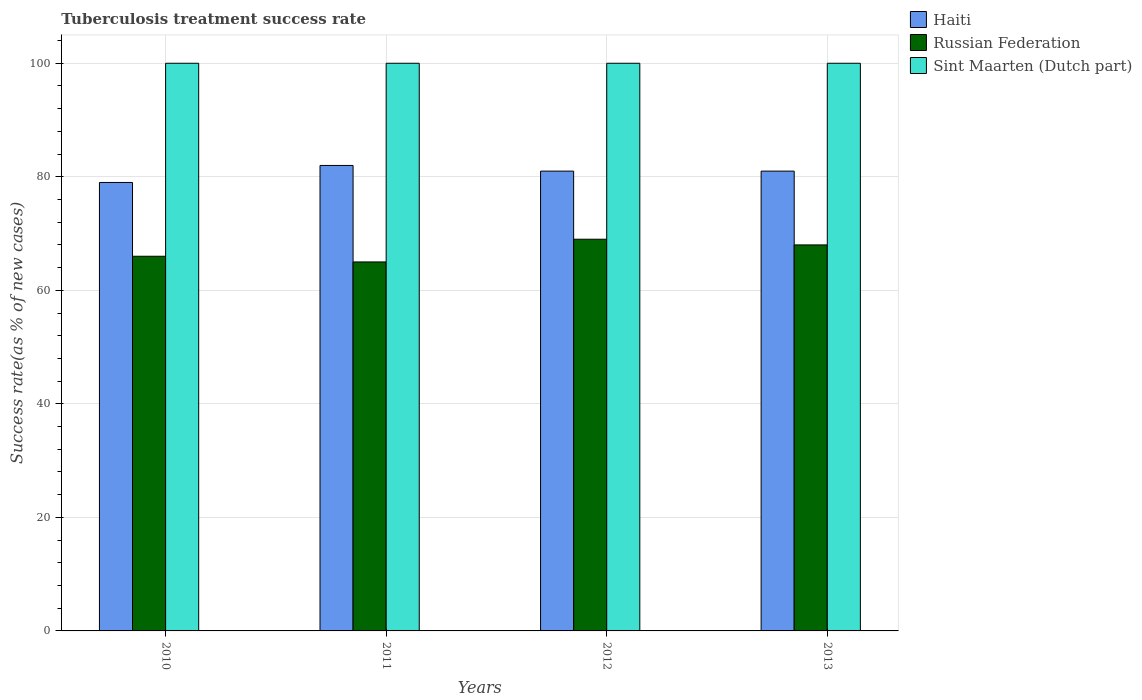How many different coloured bars are there?
Give a very brief answer. 3. How many groups of bars are there?
Provide a succinct answer. 4. Are the number of bars per tick equal to the number of legend labels?
Ensure brevity in your answer.  Yes. How many bars are there on the 4th tick from the left?
Your answer should be very brief. 3. How many bars are there on the 4th tick from the right?
Provide a short and direct response. 3. Across all years, what is the minimum tuberculosis treatment success rate in Haiti?
Ensure brevity in your answer.  79. In which year was the tuberculosis treatment success rate in Sint Maarten (Dutch part) maximum?
Your answer should be compact. 2010. What is the total tuberculosis treatment success rate in Sint Maarten (Dutch part) in the graph?
Your answer should be very brief. 400. What is the difference between the tuberculosis treatment success rate in Russian Federation in 2010 and the tuberculosis treatment success rate in Sint Maarten (Dutch part) in 2013?
Give a very brief answer. -34. What is the average tuberculosis treatment success rate in Haiti per year?
Your answer should be very brief. 80.75. In how many years, is the tuberculosis treatment success rate in Sint Maarten (Dutch part) greater than 28 %?
Provide a short and direct response. 4. What is the ratio of the tuberculosis treatment success rate in Russian Federation in 2010 to that in 2013?
Your answer should be compact. 0.97. What is the difference between the highest and the second highest tuberculosis treatment success rate in Russian Federation?
Provide a succinct answer. 1. What is the difference between the highest and the lowest tuberculosis treatment success rate in Russian Federation?
Ensure brevity in your answer.  4. In how many years, is the tuberculosis treatment success rate in Haiti greater than the average tuberculosis treatment success rate in Haiti taken over all years?
Give a very brief answer. 3. What does the 1st bar from the left in 2012 represents?
Your response must be concise. Haiti. What does the 1st bar from the right in 2013 represents?
Offer a very short reply. Sint Maarten (Dutch part). Is it the case that in every year, the sum of the tuberculosis treatment success rate in Sint Maarten (Dutch part) and tuberculosis treatment success rate in Russian Federation is greater than the tuberculosis treatment success rate in Haiti?
Ensure brevity in your answer.  Yes. How many bars are there?
Make the answer very short. 12. Are the values on the major ticks of Y-axis written in scientific E-notation?
Offer a terse response. No. Does the graph contain any zero values?
Your answer should be compact. No. Does the graph contain grids?
Offer a very short reply. Yes. How many legend labels are there?
Provide a short and direct response. 3. What is the title of the graph?
Offer a terse response. Tuberculosis treatment success rate. Does "Luxembourg" appear as one of the legend labels in the graph?
Keep it short and to the point. No. What is the label or title of the X-axis?
Provide a succinct answer. Years. What is the label or title of the Y-axis?
Give a very brief answer. Success rate(as % of new cases). What is the Success rate(as % of new cases) in Haiti in 2010?
Your response must be concise. 79. What is the Success rate(as % of new cases) in Sint Maarten (Dutch part) in 2010?
Keep it short and to the point. 100. What is the Success rate(as % of new cases) of Sint Maarten (Dutch part) in 2012?
Offer a very short reply. 100. What is the Success rate(as % of new cases) in Haiti in 2013?
Provide a short and direct response. 81. What is the Success rate(as % of new cases) in Russian Federation in 2013?
Provide a short and direct response. 68. What is the Success rate(as % of new cases) in Sint Maarten (Dutch part) in 2013?
Provide a short and direct response. 100. Across all years, what is the maximum Success rate(as % of new cases) of Haiti?
Your answer should be compact. 82. Across all years, what is the minimum Success rate(as % of new cases) of Haiti?
Your response must be concise. 79. Across all years, what is the minimum Success rate(as % of new cases) in Sint Maarten (Dutch part)?
Give a very brief answer. 100. What is the total Success rate(as % of new cases) of Haiti in the graph?
Make the answer very short. 323. What is the total Success rate(as % of new cases) in Russian Federation in the graph?
Offer a very short reply. 268. What is the difference between the Success rate(as % of new cases) in Haiti in 2010 and that in 2011?
Your answer should be compact. -3. What is the difference between the Success rate(as % of new cases) in Russian Federation in 2010 and that in 2011?
Your answer should be very brief. 1. What is the difference between the Success rate(as % of new cases) in Sint Maarten (Dutch part) in 2010 and that in 2011?
Provide a short and direct response. 0. What is the difference between the Success rate(as % of new cases) in Russian Federation in 2010 and that in 2012?
Offer a very short reply. -3. What is the difference between the Success rate(as % of new cases) in Haiti in 2010 and that in 2013?
Offer a very short reply. -2. What is the difference between the Success rate(as % of new cases) in Russian Federation in 2010 and that in 2013?
Offer a very short reply. -2. What is the difference between the Success rate(as % of new cases) of Sint Maarten (Dutch part) in 2010 and that in 2013?
Offer a terse response. 0. What is the difference between the Success rate(as % of new cases) in Haiti in 2011 and that in 2012?
Your response must be concise. 1. What is the difference between the Success rate(as % of new cases) of Russian Federation in 2011 and that in 2012?
Provide a short and direct response. -4. What is the difference between the Success rate(as % of new cases) of Haiti in 2011 and that in 2013?
Ensure brevity in your answer.  1. What is the difference between the Success rate(as % of new cases) of Sint Maarten (Dutch part) in 2011 and that in 2013?
Your response must be concise. 0. What is the difference between the Success rate(as % of new cases) in Russian Federation in 2012 and that in 2013?
Offer a terse response. 1. What is the difference between the Success rate(as % of new cases) in Haiti in 2010 and the Success rate(as % of new cases) in Russian Federation in 2011?
Keep it short and to the point. 14. What is the difference between the Success rate(as % of new cases) of Russian Federation in 2010 and the Success rate(as % of new cases) of Sint Maarten (Dutch part) in 2011?
Provide a succinct answer. -34. What is the difference between the Success rate(as % of new cases) of Russian Federation in 2010 and the Success rate(as % of new cases) of Sint Maarten (Dutch part) in 2012?
Provide a short and direct response. -34. What is the difference between the Success rate(as % of new cases) in Haiti in 2010 and the Success rate(as % of new cases) in Russian Federation in 2013?
Your answer should be compact. 11. What is the difference between the Success rate(as % of new cases) of Haiti in 2010 and the Success rate(as % of new cases) of Sint Maarten (Dutch part) in 2013?
Keep it short and to the point. -21. What is the difference between the Success rate(as % of new cases) of Russian Federation in 2010 and the Success rate(as % of new cases) of Sint Maarten (Dutch part) in 2013?
Your answer should be compact. -34. What is the difference between the Success rate(as % of new cases) in Haiti in 2011 and the Success rate(as % of new cases) in Russian Federation in 2012?
Provide a short and direct response. 13. What is the difference between the Success rate(as % of new cases) of Haiti in 2011 and the Success rate(as % of new cases) of Sint Maarten (Dutch part) in 2012?
Keep it short and to the point. -18. What is the difference between the Success rate(as % of new cases) of Russian Federation in 2011 and the Success rate(as % of new cases) of Sint Maarten (Dutch part) in 2012?
Make the answer very short. -35. What is the difference between the Success rate(as % of new cases) of Haiti in 2011 and the Success rate(as % of new cases) of Russian Federation in 2013?
Your answer should be compact. 14. What is the difference between the Success rate(as % of new cases) of Haiti in 2011 and the Success rate(as % of new cases) of Sint Maarten (Dutch part) in 2013?
Your answer should be very brief. -18. What is the difference between the Success rate(as % of new cases) of Russian Federation in 2011 and the Success rate(as % of new cases) of Sint Maarten (Dutch part) in 2013?
Your response must be concise. -35. What is the difference between the Success rate(as % of new cases) of Haiti in 2012 and the Success rate(as % of new cases) of Russian Federation in 2013?
Offer a terse response. 13. What is the difference between the Success rate(as % of new cases) in Haiti in 2012 and the Success rate(as % of new cases) in Sint Maarten (Dutch part) in 2013?
Keep it short and to the point. -19. What is the difference between the Success rate(as % of new cases) of Russian Federation in 2012 and the Success rate(as % of new cases) of Sint Maarten (Dutch part) in 2013?
Keep it short and to the point. -31. What is the average Success rate(as % of new cases) of Haiti per year?
Offer a very short reply. 80.75. What is the average Success rate(as % of new cases) of Sint Maarten (Dutch part) per year?
Offer a terse response. 100. In the year 2010, what is the difference between the Success rate(as % of new cases) in Haiti and Success rate(as % of new cases) in Sint Maarten (Dutch part)?
Provide a succinct answer. -21. In the year 2010, what is the difference between the Success rate(as % of new cases) in Russian Federation and Success rate(as % of new cases) in Sint Maarten (Dutch part)?
Give a very brief answer. -34. In the year 2011, what is the difference between the Success rate(as % of new cases) of Russian Federation and Success rate(as % of new cases) of Sint Maarten (Dutch part)?
Ensure brevity in your answer.  -35. In the year 2012, what is the difference between the Success rate(as % of new cases) of Haiti and Success rate(as % of new cases) of Russian Federation?
Make the answer very short. 12. In the year 2012, what is the difference between the Success rate(as % of new cases) in Haiti and Success rate(as % of new cases) in Sint Maarten (Dutch part)?
Provide a short and direct response. -19. In the year 2012, what is the difference between the Success rate(as % of new cases) of Russian Federation and Success rate(as % of new cases) of Sint Maarten (Dutch part)?
Your response must be concise. -31. In the year 2013, what is the difference between the Success rate(as % of new cases) of Haiti and Success rate(as % of new cases) of Russian Federation?
Make the answer very short. 13. In the year 2013, what is the difference between the Success rate(as % of new cases) in Russian Federation and Success rate(as % of new cases) in Sint Maarten (Dutch part)?
Give a very brief answer. -32. What is the ratio of the Success rate(as % of new cases) of Haiti in 2010 to that in 2011?
Your answer should be compact. 0.96. What is the ratio of the Success rate(as % of new cases) in Russian Federation in 2010 to that in 2011?
Your answer should be very brief. 1.02. What is the ratio of the Success rate(as % of new cases) of Sint Maarten (Dutch part) in 2010 to that in 2011?
Provide a short and direct response. 1. What is the ratio of the Success rate(as % of new cases) in Haiti in 2010 to that in 2012?
Your answer should be very brief. 0.98. What is the ratio of the Success rate(as % of new cases) of Russian Federation in 2010 to that in 2012?
Your answer should be very brief. 0.96. What is the ratio of the Success rate(as % of new cases) in Haiti in 2010 to that in 2013?
Make the answer very short. 0.98. What is the ratio of the Success rate(as % of new cases) in Russian Federation in 2010 to that in 2013?
Your response must be concise. 0.97. What is the ratio of the Success rate(as % of new cases) of Haiti in 2011 to that in 2012?
Give a very brief answer. 1.01. What is the ratio of the Success rate(as % of new cases) of Russian Federation in 2011 to that in 2012?
Offer a terse response. 0.94. What is the ratio of the Success rate(as % of new cases) in Haiti in 2011 to that in 2013?
Offer a terse response. 1.01. What is the ratio of the Success rate(as % of new cases) of Russian Federation in 2011 to that in 2013?
Keep it short and to the point. 0.96. What is the ratio of the Success rate(as % of new cases) of Sint Maarten (Dutch part) in 2011 to that in 2013?
Offer a very short reply. 1. What is the ratio of the Success rate(as % of new cases) in Haiti in 2012 to that in 2013?
Provide a short and direct response. 1. What is the ratio of the Success rate(as % of new cases) in Russian Federation in 2012 to that in 2013?
Your response must be concise. 1.01. What is the difference between the highest and the second highest Success rate(as % of new cases) of Haiti?
Offer a very short reply. 1. What is the difference between the highest and the second highest Success rate(as % of new cases) in Russian Federation?
Ensure brevity in your answer.  1. What is the difference between the highest and the lowest Success rate(as % of new cases) of Haiti?
Offer a very short reply. 3. What is the difference between the highest and the lowest Success rate(as % of new cases) in Russian Federation?
Your answer should be compact. 4. What is the difference between the highest and the lowest Success rate(as % of new cases) of Sint Maarten (Dutch part)?
Keep it short and to the point. 0. 